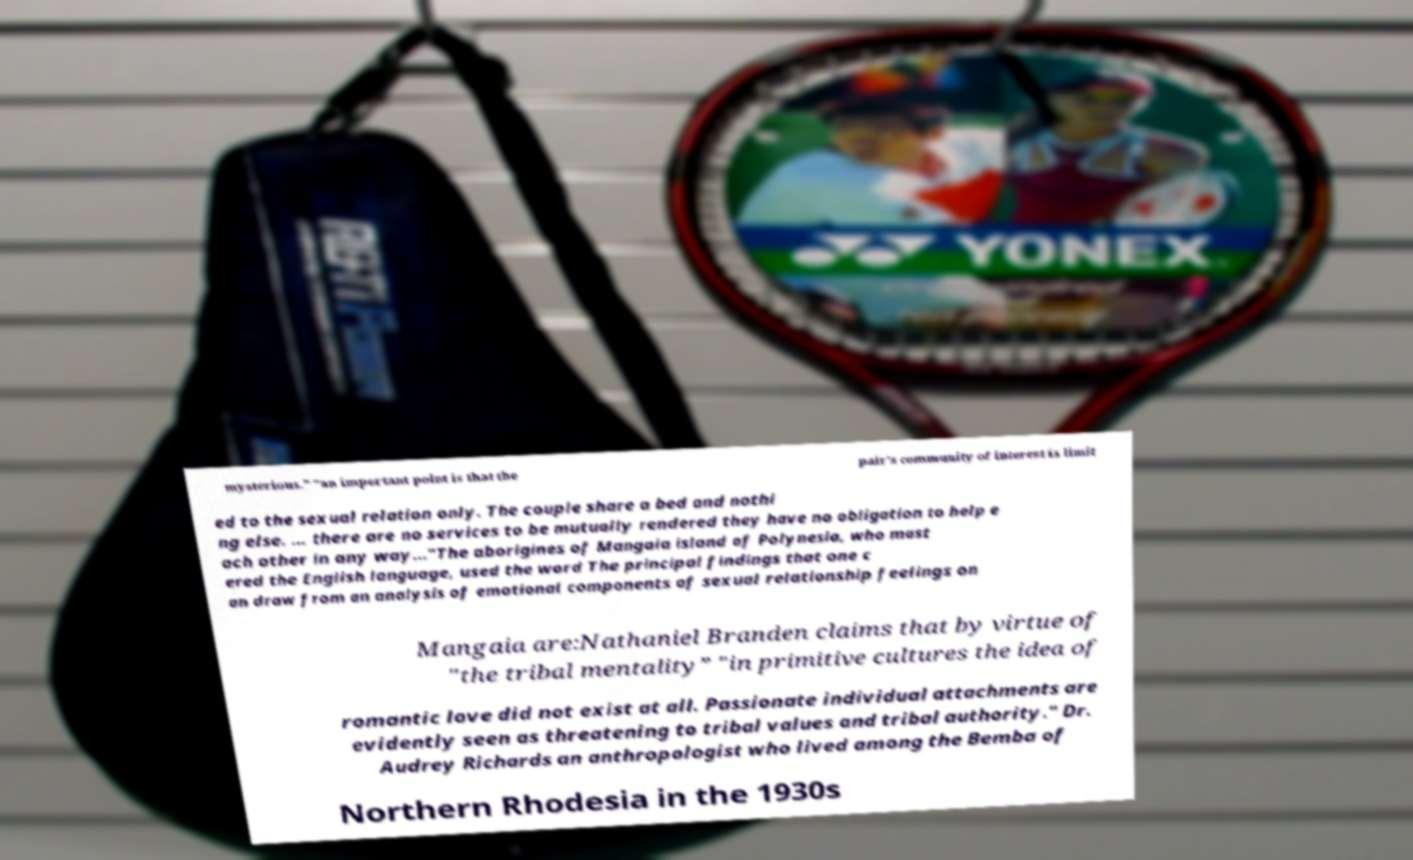Could you extract and type out the text from this image? mysterious." "an important point is that the pair's community of interest is limit ed to the sexual relation only. The couple share a bed and nothi ng else. ... there are no services to be mutually rendered they have no obligation to help e ach other in any way..."The aborigines of Mangaia island of Polynesia, who mast ered the English language, used the word The principal findings that one c an draw from an analysis of emotional components of sexual relationship feelings on Mangaia are:Nathaniel Branden claims that by virtue of "the tribal mentality” "in primitive cultures the idea of romantic love did not exist at all. Passionate individual attachments are evidently seen as threatening to tribal values and tribal authority." Dr. Audrey Richards an anthropologist who lived among the Bemba of Northern Rhodesia in the 1930s 